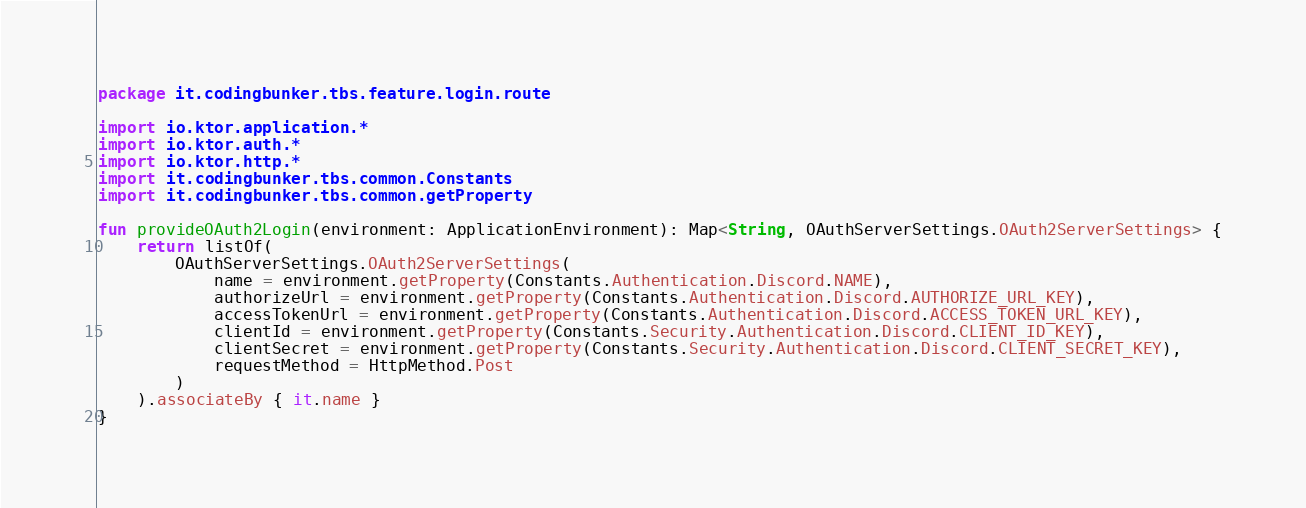Convert code to text. <code><loc_0><loc_0><loc_500><loc_500><_Kotlin_>package it.codingbunker.tbs.feature.login.route

import io.ktor.application.*
import io.ktor.auth.*
import io.ktor.http.*
import it.codingbunker.tbs.common.Constants
import it.codingbunker.tbs.common.getProperty

fun provideOAuth2Login(environment: ApplicationEnvironment): Map<String, OAuthServerSettings.OAuth2ServerSettings> {
    return listOf(
        OAuthServerSettings.OAuth2ServerSettings(
            name = environment.getProperty(Constants.Authentication.Discord.NAME),
            authorizeUrl = environment.getProperty(Constants.Authentication.Discord.AUTHORIZE_URL_KEY),
            accessTokenUrl = environment.getProperty(Constants.Authentication.Discord.ACCESS_TOKEN_URL_KEY),
            clientId = environment.getProperty(Constants.Security.Authentication.Discord.CLIENT_ID_KEY),
            clientSecret = environment.getProperty(Constants.Security.Authentication.Discord.CLIENT_SECRET_KEY),
            requestMethod = HttpMethod.Post
        )
    ).associateBy { it.name }
}
</code> 